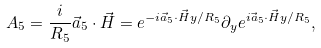<formula> <loc_0><loc_0><loc_500><loc_500>A _ { 5 } = \frac { i } { R _ { 5 } } \vec { a } _ { 5 } \cdot \vec { H } = e ^ { - i \vec { a } _ { 5 } \cdot \vec { H } y / R _ { 5 } } \partial _ { y } e ^ { i \vec { a } _ { 5 } \cdot \vec { H } y / R _ { 5 } } ,</formula> 